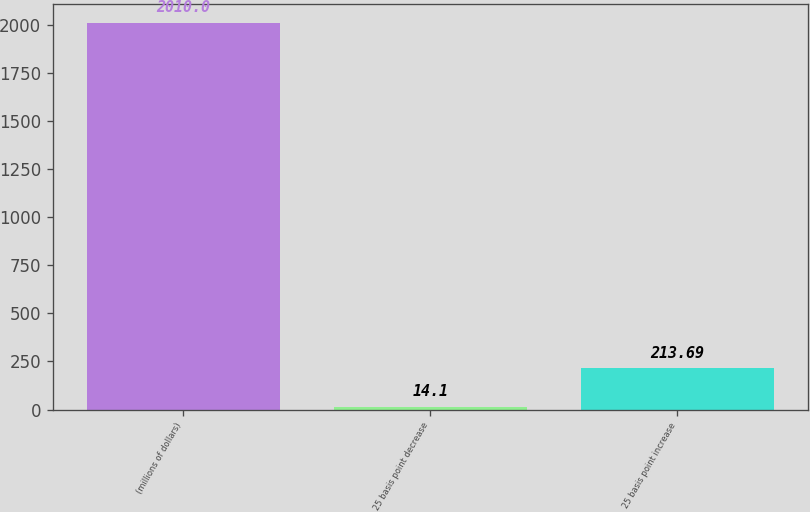Convert chart to OTSL. <chart><loc_0><loc_0><loc_500><loc_500><bar_chart><fcel>(millions of dollars)<fcel>25 basis point decrease<fcel>25 basis point increase<nl><fcel>2010<fcel>14.1<fcel>213.69<nl></chart> 